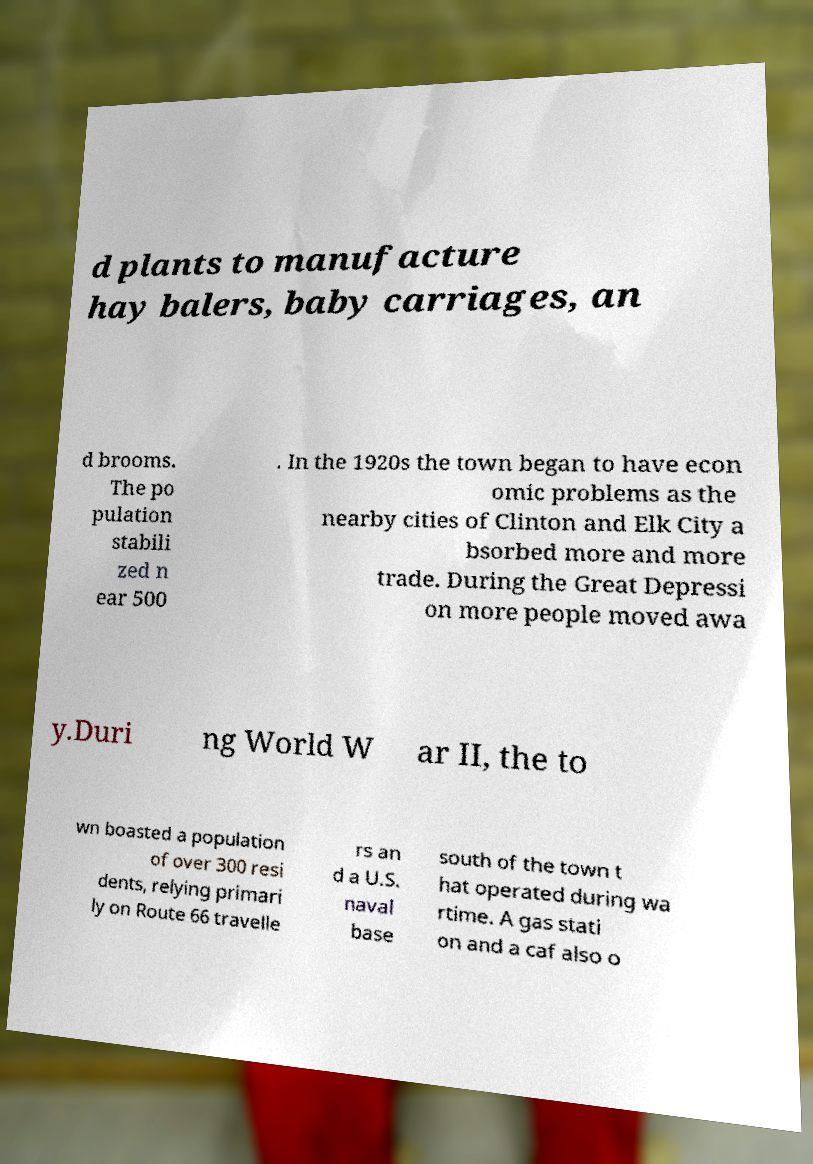Could you assist in decoding the text presented in this image and type it out clearly? d plants to manufacture hay balers, baby carriages, an d brooms. The po pulation stabili zed n ear 500 . In the 1920s the town began to have econ omic problems as the nearby cities of Clinton and Elk City a bsorbed more and more trade. During the Great Depressi on more people moved awa y.Duri ng World W ar II, the to wn boasted a population of over 300 resi dents, relying primari ly on Route 66 travelle rs an d a U.S. naval base south of the town t hat operated during wa rtime. A gas stati on and a caf also o 